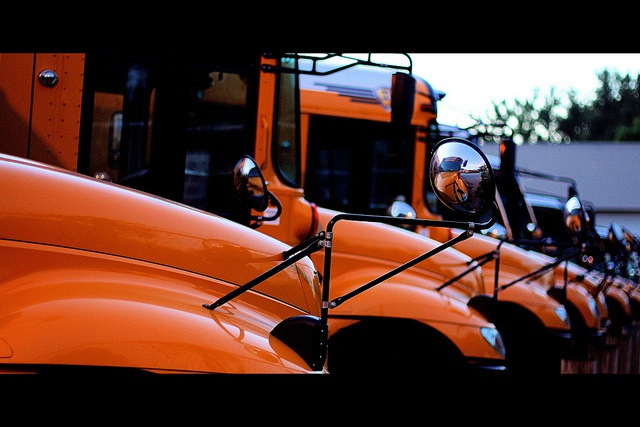Describe the objects in this image and their specific colors. I can see bus in black, red, brown, and salmon tones, bus in black, red, brown, and maroon tones, and bus in black, darkgray, and gray tones in this image. 